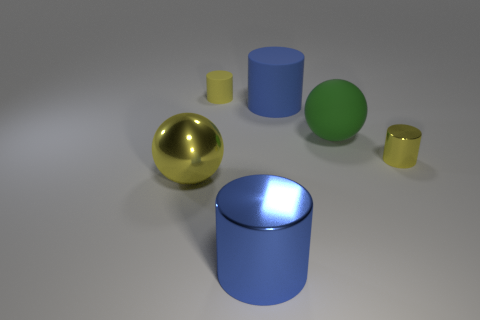What size is the object that is both to the left of the large blue metal cylinder and in front of the matte ball?
Make the answer very short. Large. What number of blocks are large yellow metal objects or tiny yellow metallic things?
Your answer should be compact. 0. There is another sphere that is the same size as the shiny sphere; what is its color?
Your answer should be very brief. Green. The tiny rubber object that is the same shape as the blue metal thing is what color?
Keep it short and to the point. Yellow. What number of things are either large objects or blue objects that are behind the yellow metallic cylinder?
Provide a succinct answer. 4. Are there fewer large blue cylinders that are to the right of the blue metallic cylinder than large cyan matte objects?
Provide a short and direct response. No. What size is the rubber cylinder that is to the right of the object that is in front of the ball on the left side of the big green sphere?
Your answer should be very brief. Large. What color is the cylinder that is both in front of the small yellow rubber thing and behind the large green rubber thing?
Offer a very short reply. Blue. How many big metallic objects are there?
Ensure brevity in your answer.  2. Is the material of the big green sphere the same as the big yellow sphere?
Provide a short and direct response. No. 